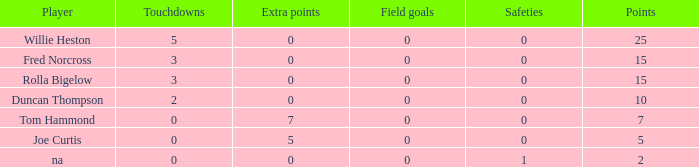Which points is the lowest one that has touchdowns fewer than 2, and an extra points of 7, and a field goals less than 0? None. 